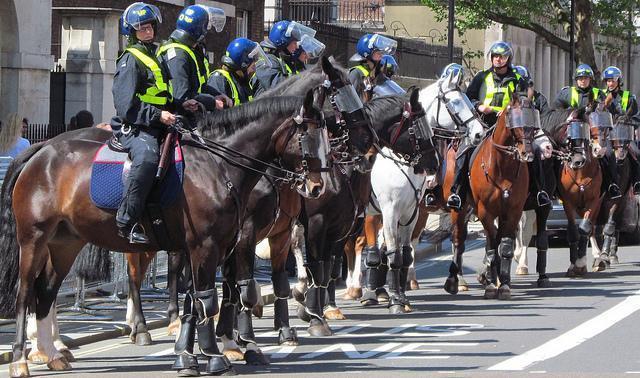How many people are riding?
Give a very brief answer. 12. How many horses are in the picture?
Give a very brief answer. 8. How many people are visible?
Give a very brief answer. 5. 